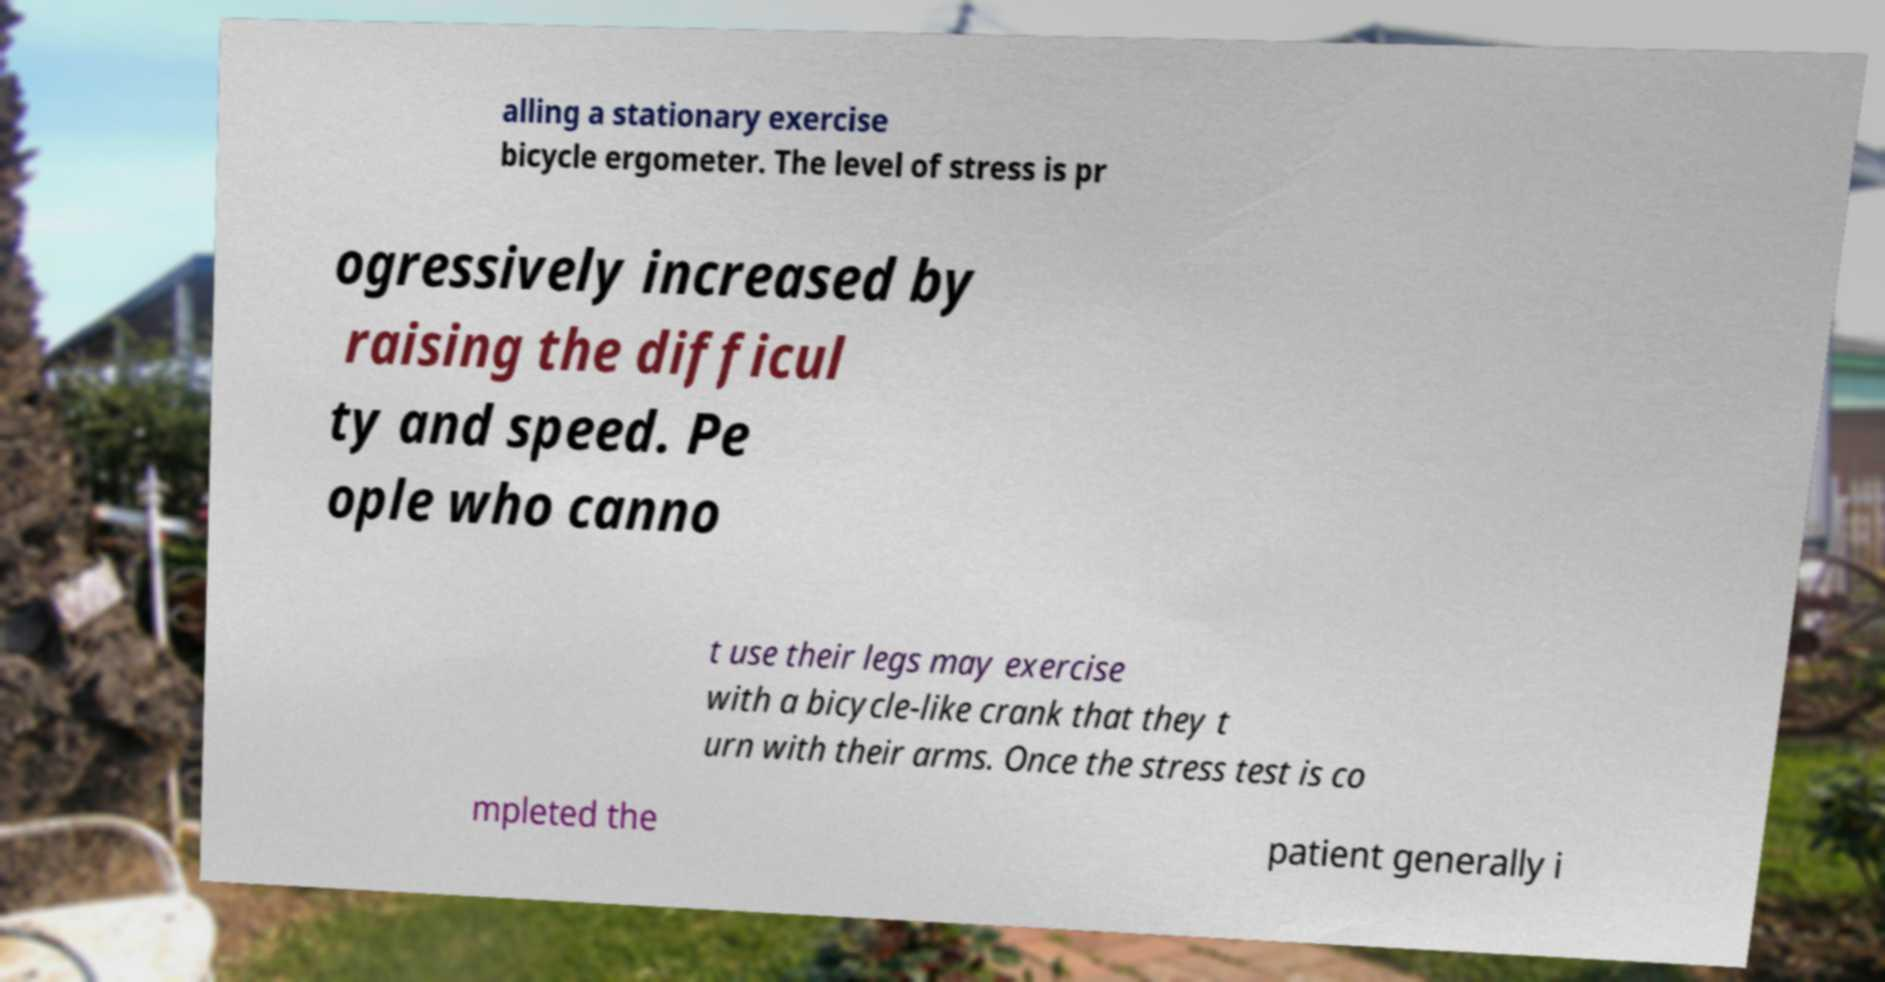Please read and relay the text visible in this image. What does it say? alling a stationary exercise bicycle ergometer. The level of stress is pr ogressively increased by raising the difficul ty and speed. Pe ople who canno t use their legs may exercise with a bicycle-like crank that they t urn with their arms. Once the stress test is co mpleted the patient generally i 